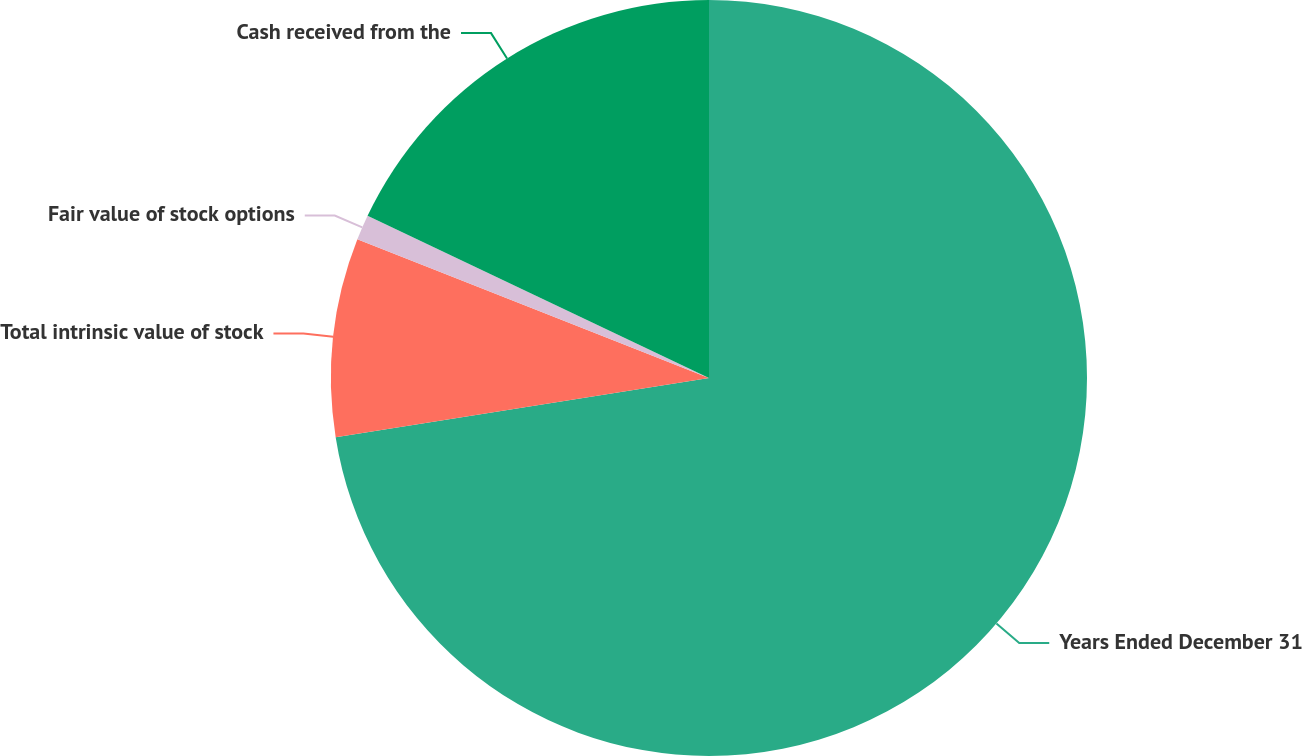Convert chart to OTSL. <chart><loc_0><loc_0><loc_500><loc_500><pie_chart><fcel>Years Ended December 31<fcel>Total intrinsic value of stock<fcel>Fair value of stock options<fcel>Cash received from the<nl><fcel>72.5%<fcel>8.48%<fcel>1.08%<fcel>17.94%<nl></chart> 